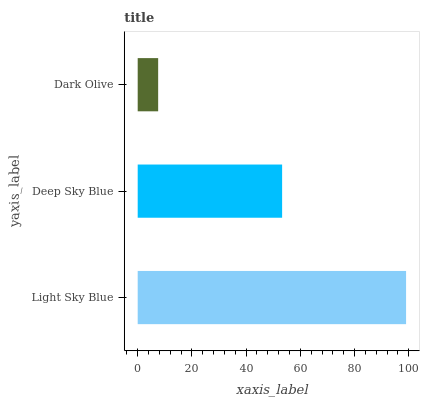Is Dark Olive the minimum?
Answer yes or no. Yes. Is Light Sky Blue the maximum?
Answer yes or no. Yes. Is Deep Sky Blue the minimum?
Answer yes or no. No. Is Deep Sky Blue the maximum?
Answer yes or no. No. Is Light Sky Blue greater than Deep Sky Blue?
Answer yes or no. Yes. Is Deep Sky Blue less than Light Sky Blue?
Answer yes or no. Yes. Is Deep Sky Blue greater than Light Sky Blue?
Answer yes or no. No. Is Light Sky Blue less than Deep Sky Blue?
Answer yes or no. No. Is Deep Sky Blue the high median?
Answer yes or no. Yes. Is Deep Sky Blue the low median?
Answer yes or no. Yes. Is Dark Olive the high median?
Answer yes or no. No. Is Dark Olive the low median?
Answer yes or no. No. 